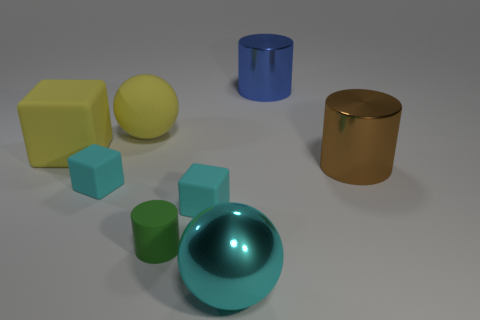There is a cyan object that is on the right side of the yellow rubber sphere and behind the large cyan object; how big is it?
Ensure brevity in your answer.  Small. There is a object that is the same color as the big rubber sphere; what is its material?
Your answer should be very brief. Rubber. Does the rubber cylinder have the same color as the big matte sphere?
Keep it short and to the point. No. What material is the other ball that is the same size as the cyan metal ball?
Provide a short and direct response. Rubber. Are the blue cylinder and the yellow block made of the same material?
Provide a succinct answer. No. What number of small cyan cubes have the same material as the green object?
Offer a terse response. 2. What number of objects are tiny cyan objects that are to the left of the rubber cylinder or cyan rubber blocks to the right of the yellow sphere?
Give a very brief answer. 2. Is the number of big cyan shiny objects left of the small green cylinder greater than the number of blue shiny objects that are on the left side of the large blue cylinder?
Give a very brief answer. No. What color is the big ball behind the large yellow rubber block?
Provide a short and direct response. Yellow. Is there a tiny brown rubber thing that has the same shape as the tiny green matte thing?
Keep it short and to the point. No. 